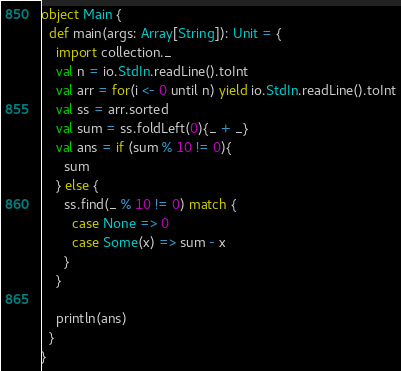Convert code to text. <code><loc_0><loc_0><loc_500><loc_500><_Scala_>object Main {
  def main(args: Array[String]): Unit = {
    import collection._
    val n = io.StdIn.readLine().toInt
    val arr = for(i <- 0 until n) yield io.StdIn.readLine().toInt
    val ss = arr.sorted
    val sum = ss.foldLeft(0){_ + _}
    val ans = if (sum % 10 != 0){
      sum
    } else {
      ss.find(_ % 10 != 0) match {
        case None => 0
        case Some(x) => sum - x
      }
    }

    println(ans)
  }
}</code> 